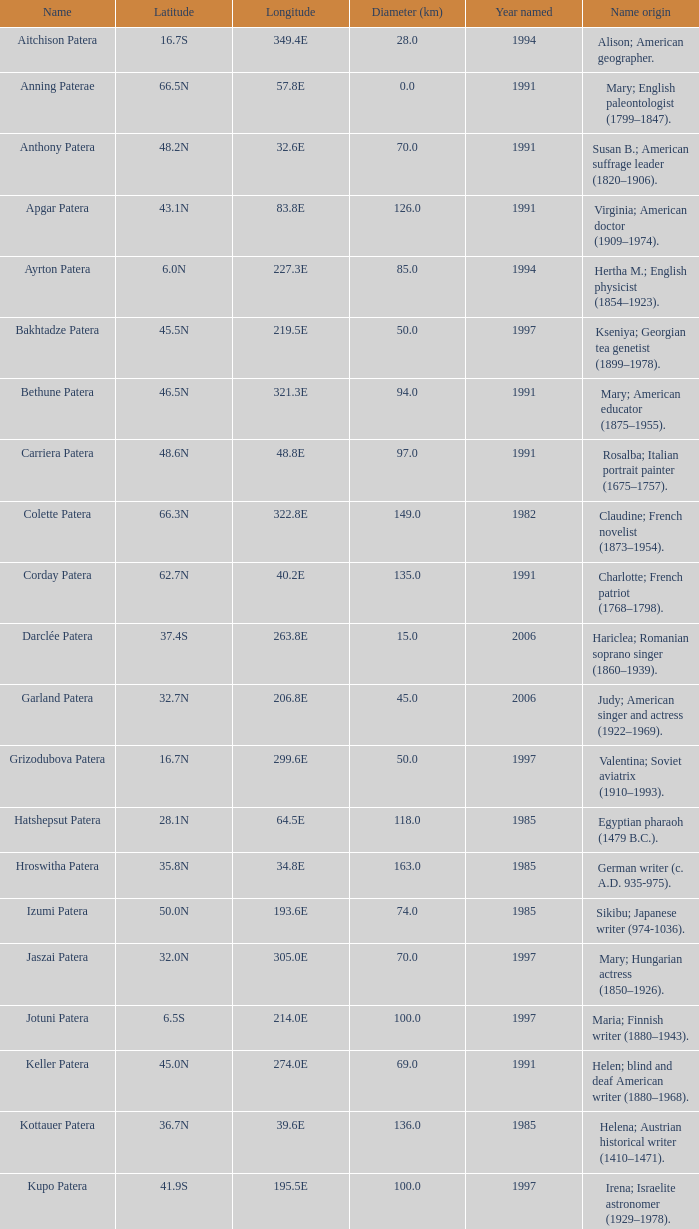What is the diameter in km of the feature named Colette Patera?  149.0. 